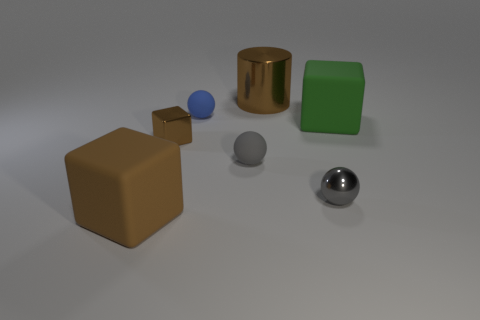How many gray things are either metallic blocks or small metal objects?
Ensure brevity in your answer.  1. Are there the same number of brown blocks behind the small blue matte sphere and big yellow metal balls?
Your answer should be compact. Yes. What color is the other tiny rubber object that is the same shape as the small gray rubber thing?
Provide a short and direct response. Blue. What number of other matte objects are the same shape as the small brown object?
Offer a terse response. 2. There is another cube that is the same color as the small shiny cube; what is its material?
Your response must be concise. Rubber. What number of tiny yellow rubber cylinders are there?
Your answer should be very brief. 0. Is there a brown sphere made of the same material as the green object?
Keep it short and to the point. No. There is a rubber cube that is the same color as the cylinder; what size is it?
Offer a terse response. Large. There is a cube that is to the right of the blue matte sphere; is it the same size as the block in front of the gray metallic thing?
Make the answer very short. Yes. How big is the cylinder to the left of the small gray metal ball?
Your answer should be very brief. Large. 